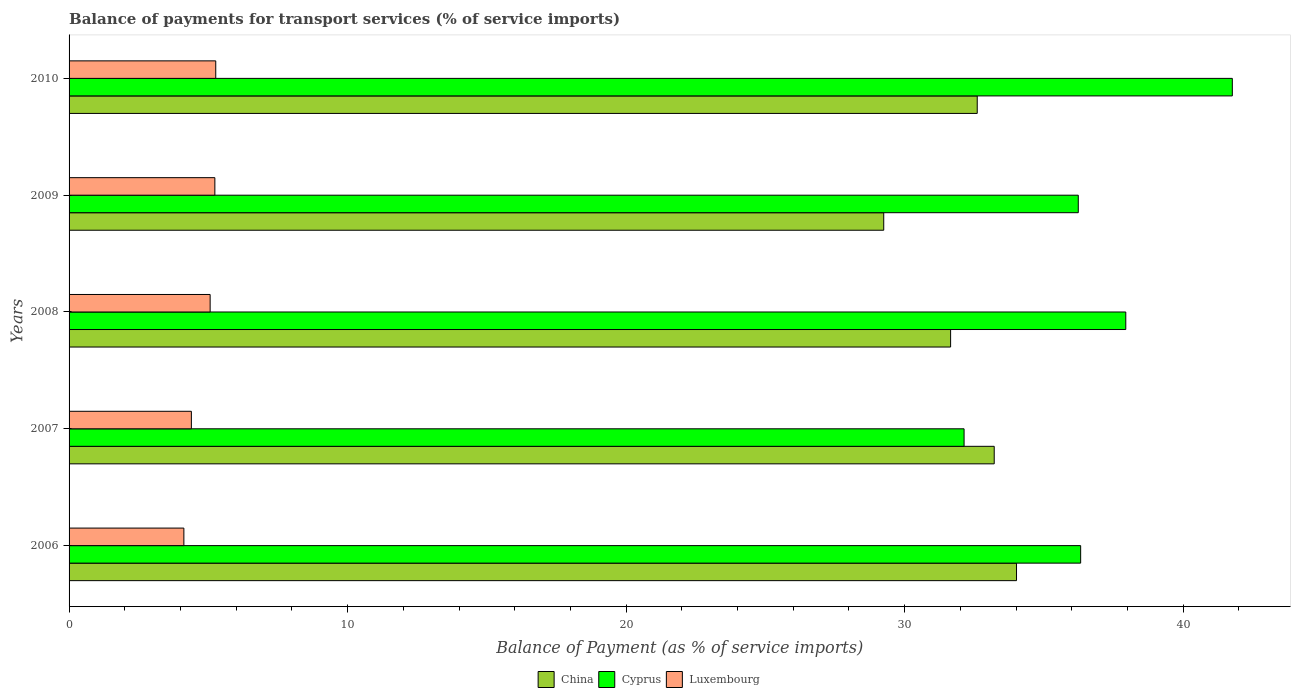How many different coloured bars are there?
Make the answer very short. 3. How many groups of bars are there?
Ensure brevity in your answer.  5. Are the number of bars per tick equal to the number of legend labels?
Your answer should be very brief. Yes. Are the number of bars on each tick of the Y-axis equal?
Give a very brief answer. Yes. How many bars are there on the 2nd tick from the top?
Provide a short and direct response. 3. What is the label of the 1st group of bars from the top?
Your answer should be compact. 2010. In how many cases, is the number of bars for a given year not equal to the number of legend labels?
Provide a succinct answer. 0. What is the balance of payments for transport services in China in 2010?
Keep it short and to the point. 32.61. Across all years, what is the maximum balance of payments for transport services in Cyprus?
Give a very brief answer. 41.76. Across all years, what is the minimum balance of payments for transport services in Cyprus?
Your response must be concise. 32.13. In which year was the balance of payments for transport services in China maximum?
Your answer should be compact. 2006. What is the total balance of payments for transport services in China in the graph?
Your answer should be very brief. 160.74. What is the difference between the balance of payments for transport services in Luxembourg in 2008 and that in 2010?
Keep it short and to the point. -0.2. What is the difference between the balance of payments for transport services in China in 2010 and the balance of payments for transport services in Luxembourg in 2007?
Keep it short and to the point. 28.21. What is the average balance of payments for transport services in Luxembourg per year?
Your response must be concise. 4.82. In the year 2008, what is the difference between the balance of payments for transport services in China and balance of payments for transport services in Luxembourg?
Provide a short and direct response. 26.58. What is the ratio of the balance of payments for transport services in Cyprus in 2007 to that in 2009?
Offer a very short reply. 0.89. Is the balance of payments for transport services in China in 2007 less than that in 2010?
Give a very brief answer. No. Is the difference between the balance of payments for transport services in China in 2006 and 2008 greater than the difference between the balance of payments for transport services in Luxembourg in 2006 and 2008?
Provide a short and direct response. Yes. What is the difference between the highest and the second highest balance of payments for transport services in China?
Your answer should be very brief. 0.8. What is the difference between the highest and the lowest balance of payments for transport services in Cyprus?
Provide a short and direct response. 9.63. Is the sum of the balance of payments for transport services in China in 2006 and 2008 greater than the maximum balance of payments for transport services in Cyprus across all years?
Offer a very short reply. Yes. Is it the case that in every year, the sum of the balance of payments for transport services in Luxembourg and balance of payments for transport services in China is greater than the balance of payments for transport services in Cyprus?
Your answer should be very brief. No. Are the values on the major ticks of X-axis written in scientific E-notation?
Ensure brevity in your answer.  No. Does the graph contain any zero values?
Your response must be concise. No. Where does the legend appear in the graph?
Offer a terse response. Bottom center. How are the legend labels stacked?
Offer a terse response. Horizontal. What is the title of the graph?
Ensure brevity in your answer.  Balance of payments for transport services (% of service imports). Does "Samoa" appear as one of the legend labels in the graph?
Give a very brief answer. No. What is the label or title of the X-axis?
Offer a very short reply. Balance of Payment (as % of service imports). What is the label or title of the Y-axis?
Your answer should be very brief. Years. What is the Balance of Payment (as % of service imports) of China in 2006?
Provide a succinct answer. 34.02. What is the Balance of Payment (as % of service imports) in Cyprus in 2006?
Give a very brief answer. 36.32. What is the Balance of Payment (as % of service imports) of Luxembourg in 2006?
Offer a very short reply. 4.12. What is the Balance of Payment (as % of service imports) in China in 2007?
Provide a succinct answer. 33.22. What is the Balance of Payment (as % of service imports) in Cyprus in 2007?
Keep it short and to the point. 32.13. What is the Balance of Payment (as % of service imports) of Luxembourg in 2007?
Keep it short and to the point. 4.39. What is the Balance of Payment (as % of service imports) in China in 2008?
Offer a very short reply. 31.65. What is the Balance of Payment (as % of service imports) of Cyprus in 2008?
Your answer should be compact. 37.94. What is the Balance of Payment (as % of service imports) in Luxembourg in 2008?
Your response must be concise. 5.07. What is the Balance of Payment (as % of service imports) in China in 2009?
Your response must be concise. 29.25. What is the Balance of Payment (as % of service imports) of Cyprus in 2009?
Make the answer very short. 36.23. What is the Balance of Payment (as % of service imports) of Luxembourg in 2009?
Provide a succinct answer. 5.23. What is the Balance of Payment (as % of service imports) in China in 2010?
Your answer should be compact. 32.61. What is the Balance of Payment (as % of service imports) of Cyprus in 2010?
Give a very brief answer. 41.76. What is the Balance of Payment (as % of service imports) of Luxembourg in 2010?
Provide a short and direct response. 5.27. Across all years, what is the maximum Balance of Payment (as % of service imports) in China?
Give a very brief answer. 34.02. Across all years, what is the maximum Balance of Payment (as % of service imports) of Cyprus?
Your answer should be compact. 41.76. Across all years, what is the maximum Balance of Payment (as % of service imports) of Luxembourg?
Offer a terse response. 5.27. Across all years, what is the minimum Balance of Payment (as % of service imports) of China?
Your response must be concise. 29.25. Across all years, what is the minimum Balance of Payment (as % of service imports) in Cyprus?
Make the answer very short. 32.13. Across all years, what is the minimum Balance of Payment (as % of service imports) of Luxembourg?
Ensure brevity in your answer.  4.12. What is the total Balance of Payment (as % of service imports) in China in the graph?
Provide a short and direct response. 160.74. What is the total Balance of Payment (as % of service imports) of Cyprus in the graph?
Give a very brief answer. 184.39. What is the total Balance of Payment (as % of service imports) of Luxembourg in the graph?
Make the answer very short. 24.08. What is the difference between the Balance of Payment (as % of service imports) in China in 2006 and that in 2007?
Make the answer very short. 0.8. What is the difference between the Balance of Payment (as % of service imports) of Cyprus in 2006 and that in 2007?
Provide a short and direct response. 4.19. What is the difference between the Balance of Payment (as % of service imports) in Luxembourg in 2006 and that in 2007?
Your answer should be very brief. -0.27. What is the difference between the Balance of Payment (as % of service imports) of China in 2006 and that in 2008?
Your response must be concise. 2.37. What is the difference between the Balance of Payment (as % of service imports) in Cyprus in 2006 and that in 2008?
Provide a succinct answer. -1.62. What is the difference between the Balance of Payment (as % of service imports) of Luxembourg in 2006 and that in 2008?
Make the answer very short. -0.94. What is the difference between the Balance of Payment (as % of service imports) of China in 2006 and that in 2009?
Provide a short and direct response. 4.77. What is the difference between the Balance of Payment (as % of service imports) of Cyprus in 2006 and that in 2009?
Give a very brief answer. 0.09. What is the difference between the Balance of Payment (as % of service imports) of Luxembourg in 2006 and that in 2009?
Your response must be concise. -1.11. What is the difference between the Balance of Payment (as % of service imports) of China in 2006 and that in 2010?
Give a very brief answer. 1.41. What is the difference between the Balance of Payment (as % of service imports) in Cyprus in 2006 and that in 2010?
Your response must be concise. -5.45. What is the difference between the Balance of Payment (as % of service imports) in Luxembourg in 2006 and that in 2010?
Provide a short and direct response. -1.14. What is the difference between the Balance of Payment (as % of service imports) of China in 2007 and that in 2008?
Keep it short and to the point. 1.57. What is the difference between the Balance of Payment (as % of service imports) of Cyprus in 2007 and that in 2008?
Your answer should be very brief. -5.81. What is the difference between the Balance of Payment (as % of service imports) of Luxembourg in 2007 and that in 2008?
Give a very brief answer. -0.67. What is the difference between the Balance of Payment (as % of service imports) in China in 2007 and that in 2009?
Ensure brevity in your answer.  3.97. What is the difference between the Balance of Payment (as % of service imports) of Cyprus in 2007 and that in 2009?
Provide a succinct answer. -4.1. What is the difference between the Balance of Payment (as % of service imports) in Luxembourg in 2007 and that in 2009?
Ensure brevity in your answer.  -0.84. What is the difference between the Balance of Payment (as % of service imports) of China in 2007 and that in 2010?
Your response must be concise. 0.61. What is the difference between the Balance of Payment (as % of service imports) in Cyprus in 2007 and that in 2010?
Keep it short and to the point. -9.63. What is the difference between the Balance of Payment (as % of service imports) of Luxembourg in 2007 and that in 2010?
Your answer should be compact. -0.87. What is the difference between the Balance of Payment (as % of service imports) of China in 2008 and that in 2009?
Offer a terse response. 2.4. What is the difference between the Balance of Payment (as % of service imports) in Cyprus in 2008 and that in 2009?
Make the answer very short. 1.71. What is the difference between the Balance of Payment (as % of service imports) of Luxembourg in 2008 and that in 2009?
Give a very brief answer. -0.17. What is the difference between the Balance of Payment (as % of service imports) in China in 2008 and that in 2010?
Provide a short and direct response. -0.96. What is the difference between the Balance of Payment (as % of service imports) of Cyprus in 2008 and that in 2010?
Your answer should be very brief. -3.83. What is the difference between the Balance of Payment (as % of service imports) of Luxembourg in 2008 and that in 2010?
Offer a terse response. -0.2. What is the difference between the Balance of Payment (as % of service imports) in China in 2009 and that in 2010?
Give a very brief answer. -3.36. What is the difference between the Balance of Payment (as % of service imports) in Cyprus in 2009 and that in 2010?
Ensure brevity in your answer.  -5.53. What is the difference between the Balance of Payment (as % of service imports) in Luxembourg in 2009 and that in 2010?
Make the answer very short. -0.03. What is the difference between the Balance of Payment (as % of service imports) in China in 2006 and the Balance of Payment (as % of service imports) in Cyprus in 2007?
Keep it short and to the point. 1.88. What is the difference between the Balance of Payment (as % of service imports) in China in 2006 and the Balance of Payment (as % of service imports) in Luxembourg in 2007?
Provide a succinct answer. 29.62. What is the difference between the Balance of Payment (as % of service imports) in Cyprus in 2006 and the Balance of Payment (as % of service imports) in Luxembourg in 2007?
Your answer should be compact. 31.93. What is the difference between the Balance of Payment (as % of service imports) in China in 2006 and the Balance of Payment (as % of service imports) in Cyprus in 2008?
Your answer should be compact. -3.92. What is the difference between the Balance of Payment (as % of service imports) in China in 2006 and the Balance of Payment (as % of service imports) in Luxembourg in 2008?
Provide a short and direct response. 28.95. What is the difference between the Balance of Payment (as % of service imports) of Cyprus in 2006 and the Balance of Payment (as % of service imports) of Luxembourg in 2008?
Ensure brevity in your answer.  31.25. What is the difference between the Balance of Payment (as % of service imports) in China in 2006 and the Balance of Payment (as % of service imports) in Cyprus in 2009?
Provide a succinct answer. -2.22. What is the difference between the Balance of Payment (as % of service imports) in China in 2006 and the Balance of Payment (as % of service imports) in Luxembourg in 2009?
Your answer should be very brief. 28.78. What is the difference between the Balance of Payment (as % of service imports) of Cyprus in 2006 and the Balance of Payment (as % of service imports) of Luxembourg in 2009?
Give a very brief answer. 31.08. What is the difference between the Balance of Payment (as % of service imports) in China in 2006 and the Balance of Payment (as % of service imports) in Cyprus in 2010?
Provide a succinct answer. -7.75. What is the difference between the Balance of Payment (as % of service imports) of China in 2006 and the Balance of Payment (as % of service imports) of Luxembourg in 2010?
Your response must be concise. 28.75. What is the difference between the Balance of Payment (as % of service imports) in Cyprus in 2006 and the Balance of Payment (as % of service imports) in Luxembourg in 2010?
Provide a succinct answer. 31.05. What is the difference between the Balance of Payment (as % of service imports) of China in 2007 and the Balance of Payment (as % of service imports) of Cyprus in 2008?
Your answer should be very brief. -4.72. What is the difference between the Balance of Payment (as % of service imports) of China in 2007 and the Balance of Payment (as % of service imports) of Luxembourg in 2008?
Your answer should be very brief. 28.15. What is the difference between the Balance of Payment (as % of service imports) of Cyprus in 2007 and the Balance of Payment (as % of service imports) of Luxembourg in 2008?
Offer a very short reply. 27.07. What is the difference between the Balance of Payment (as % of service imports) of China in 2007 and the Balance of Payment (as % of service imports) of Cyprus in 2009?
Your response must be concise. -3.02. What is the difference between the Balance of Payment (as % of service imports) in China in 2007 and the Balance of Payment (as % of service imports) in Luxembourg in 2009?
Provide a short and direct response. 27.98. What is the difference between the Balance of Payment (as % of service imports) of Cyprus in 2007 and the Balance of Payment (as % of service imports) of Luxembourg in 2009?
Offer a very short reply. 26.9. What is the difference between the Balance of Payment (as % of service imports) in China in 2007 and the Balance of Payment (as % of service imports) in Cyprus in 2010?
Your answer should be very brief. -8.55. What is the difference between the Balance of Payment (as % of service imports) in China in 2007 and the Balance of Payment (as % of service imports) in Luxembourg in 2010?
Give a very brief answer. 27.95. What is the difference between the Balance of Payment (as % of service imports) of Cyprus in 2007 and the Balance of Payment (as % of service imports) of Luxembourg in 2010?
Make the answer very short. 26.87. What is the difference between the Balance of Payment (as % of service imports) in China in 2008 and the Balance of Payment (as % of service imports) in Cyprus in 2009?
Offer a terse response. -4.58. What is the difference between the Balance of Payment (as % of service imports) of China in 2008 and the Balance of Payment (as % of service imports) of Luxembourg in 2009?
Offer a terse response. 26.42. What is the difference between the Balance of Payment (as % of service imports) of Cyprus in 2008 and the Balance of Payment (as % of service imports) of Luxembourg in 2009?
Offer a very short reply. 32.7. What is the difference between the Balance of Payment (as % of service imports) of China in 2008 and the Balance of Payment (as % of service imports) of Cyprus in 2010?
Your answer should be very brief. -10.11. What is the difference between the Balance of Payment (as % of service imports) in China in 2008 and the Balance of Payment (as % of service imports) in Luxembourg in 2010?
Keep it short and to the point. 26.38. What is the difference between the Balance of Payment (as % of service imports) of Cyprus in 2008 and the Balance of Payment (as % of service imports) of Luxembourg in 2010?
Your answer should be compact. 32.67. What is the difference between the Balance of Payment (as % of service imports) in China in 2009 and the Balance of Payment (as % of service imports) in Cyprus in 2010?
Make the answer very short. -12.52. What is the difference between the Balance of Payment (as % of service imports) in China in 2009 and the Balance of Payment (as % of service imports) in Luxembourg in 2010?
Offer a very short reply. 23.98. What is the difference between the Balance of Payment (as % of service imports) in Cyprus in 2009 and the Balance of Payment (as % of service imports) in Luxembourg in 2010?
Make the answer very short. 30.97. What is the average Balance of Payment (as % of service imports) in China per year?
Offer a terse response. 32.15. What is the average Balance of Payment (as % of service imports) in Cyprus per year?
Make the answer very short. 36.88. What is the average Balance of Payment (as % of service imports) of Luxembourg per year?
Give a very brief answer. 4.82. In the year 2006, what is the difference between the Balance of Payment (as % of service imports) of China and Balance of Payment (as % of service imports) of Cyprus?
Provide a succinct answer. -2.3. In the year 2006, what is the difference between the Balance of Payment (as % of service imports) of China and Balance of Payment (as % of service imports) of Luxembourg?
Give a very brief answer. 29.89. In the year 2006, what is the difference between the Balance of Payment (as % of service imports) of Cyprus and Balance of Payment (as % of service imports) of Luxembourg?
Provide a short and direct response. 32.2. In the year 2007, what is the difference between the Balance of Payment (as % of service imports) in China and Balance of Payment (as % of service imports) in Cyprus?
Make the answer very short. 1.08. In the year 2007, what is the difference between the Balance of Payment (as % of service imports) of China and Balance of Payment (as % of service imports) of Luxembourg?
Ensure brevity in your answer.  28.82. In the year 2007, what is the difference between the Balance of Payment (as % of service imports) in Cyprus and Balance of Payment (as % of service imports) in Luxembourg?
Your response must be concise. 27.74. In the year 2008, what is the difference between the Balance of Payment (as % of service imports) of China and Balance of Payment (as % of service imports) of Cyprus?
Provide a short and direct response. -6.29. In the year 2008, what is the difference between the Balance of Payment (as % of service imports) in China and Balance of Payment (as % of service imports) in Luxembourg?
Offer a terse response. 26.58. In the year 2008, what is the difference between the Balance of Payment (as % of service imports) in Cyprus and Balance of Payment (as % of service imports) in Luxembourg?
Offer a terse response. 32.87. In the year 2009, what is the difference between the Balance of Payment (as % of service imports) in China and Balance of Payment (as % of service imports) in Cyprus?
Your answer should be very brief. -6.98. In the year 2009, what is the difference between the Balance of Payment (as % of service imports) in China and Balance of Payment (as % of service imports) in Luxembourg?
Make the answer very short. 24.01. In the year 2009, what is the difference between the Balance of Payment (as % of service imports) in Cyprus and Balance of Payment (as % of service imports) in Luxembourg?
Make the answer very short. 31. In the year 2010, what is the difference between the Balance of Payment (as % of service imports) in China and Balance of Payment (as % of service imports) in Cyprus?
Make the answer very short. -9.16. In the year 2010, what is the difference between the Balance of Payment (as % of service imports) in China and Balance of Payment (as % of service imports) in Luxembourg?
Keep it short and to the point. 27.34. In the year 2010, what is the difference between the Balance of Payment (as % of service imports) of Cyprus and Balance of Payment (as % of service imports) of Luxembourg?
Keep it short and to the point. 36.5. What is the ratio of the Balance of Payment (as % of service imports) in China in 2006 to that in 2007?
Offer a terse response. 1.02. What is the ratio of the Balance of Payment (as % of service imports) in Cyprus in 2006 to that in 2007?
Give a very brief answer. 1.13. What is the ratio of the Balance of Payment (as % of service imports) in Luxembourg in 2006 to that in 2007?
Give a very brief answer. 0.94. What is the ratio of the Balance of Payment (as % of service imports) of China in 2006 to that in 2008?
Your answer should be compact. 1.07. What is the ratio of the Balance of Payment (as % of service imports) of Cyprus in 2006 to that in 2008?
Your answer should be very brief. 0.96. What is the ratio of the Balance of Payment (as % of service imports) of Luxembourg in 2006 to that in 2008?
Offer a very short reply. 0.81. What is the ratio of the Balance of Payment (as % of service imports) of China in 2006 to that in 2009?
Ensure brevity in your answer.  1.16. What is the ratio of the Balance of Payment (as % of service imports) of Cyprus in 2006 to that in 2009?
Your answer should be very brief. 1. What is the ratio of the Balance of Payment (as % of service imports) in Luxembourg in 2006 to that in 2009?
Ensure brevity in your answer.  0.79. What is the ratio of the Balance of Payment (as % of service imports) in China in 2006 to that in 2010?
Provide a succinct answer. 1.04. What is the ratio of the Balance of Payment (as % of service imports) of Cyprus in 2006 to that in 2010?
Offer a very short reply. 0.87. What is the ratio of the Balance of Payment (as % of service imports) in Luxembourg in 2006 to that in 2010?
Provide a short and direct response. 0.78. What is the ratio of the Balance of Payment (as % of service imports) of China in 2007 to that in 2008?
Your answer should be compact. 1.05. What is the ratio of the Balance of Payment (as % of service imports) of Cyprus in 2007 to that in 2008?
Your answer should be compact. 0.85. What is the ratio of the Balance of Payment (as % of service imports) in Luxembourg in 2007 to that in 2008?
Offer a terse response. 0.87. What is the ratio of the Balance of Payment (as % of service imports) of China in 2007 to that in 2009?
Provide a succinct answer. 1.14. What is the ratio of the Balance of Payment (as % of service imports) in Cyprus in 2007 to that in 2009?
Offer a very short reply. 0.89. What is the ratio of the Balance of Payment (as % of service imports) of Luxembourg in 2007 to that in 2009?
Your response must be concise. 0.84. What is the ratio of the Balance of Payment (as % of service imports) in China in 2007 to that in 2010?
Keep it short and to the point. 1.02. What is the ratio of the Balance of Payment (as % of service imports) in Cyprus in 2007 to that in 2010?
Provide a succinct answer. 0.77. What is the ratio of the Balance of Payment (as % of service imports) of Luxembourg in 2007 to that in 2010?
Provide a succinct answer. 0.83. What is the ratio of the Balance of Payment (as % of service imports) of China in 2008 to that in 2009?
Give a very brief answer. 1.08. What is the ratio of the Balance of Payment (as % of service imports) in Cyprus in 2008 to that in 2009?
Your response must be concise. 1.05. What is the ratio of the Balance of Payment (as % of service imports) of China in 2008 to that in 2010?
Offer a very short reply. 0.97. What is the ratio of the Balance of Payment (as % of service imports) of Cyprus in 2008 to that in 2010?
Offer a very short reply. 0.91. What is the ratio of the Balance of Payment (as % of service imports) of Luxembourg in 2008 to that in 2010?
Offer a very short reply. 0.96. What is the ratio of the Balance of Payment (as % of service imports) in China in 2009 to that in 2010?
Provide a succinct answer. 0.9. What is the ratio of the Balance of Payment (as % of service imports) in Cyprus in 2009 to that in 2010?
Ensure brevity in your answer.  0.87. What is the difference between the highest and the second highest Balance of Payment (as % of service imports) in China?
Make the answer very short. 0.8. What is the difference between the highest and the second highest Balance of Payment (as % of service imports) of Cyprus?
Your answer should be compact. 3.83. What is the difference between the highest and the second highest Balance of Payment (as % of service imports) in Luxembourg?
Your answer should be very brief. 0.03. What is the difference between the highest and the lowest Balance of Payment (as % of service imports) in China?
Your answer should be compact. 4.77. What is the difference between the highest and the lowest Balance of Payment (as % of service imports) in Cyprus?
Your answer should be compact. 9.63. What is the difference between the highest and the lowest Balance of Payment (as % of service imports) of Luxembourg?
Provide a short and direct response. 1.14. 